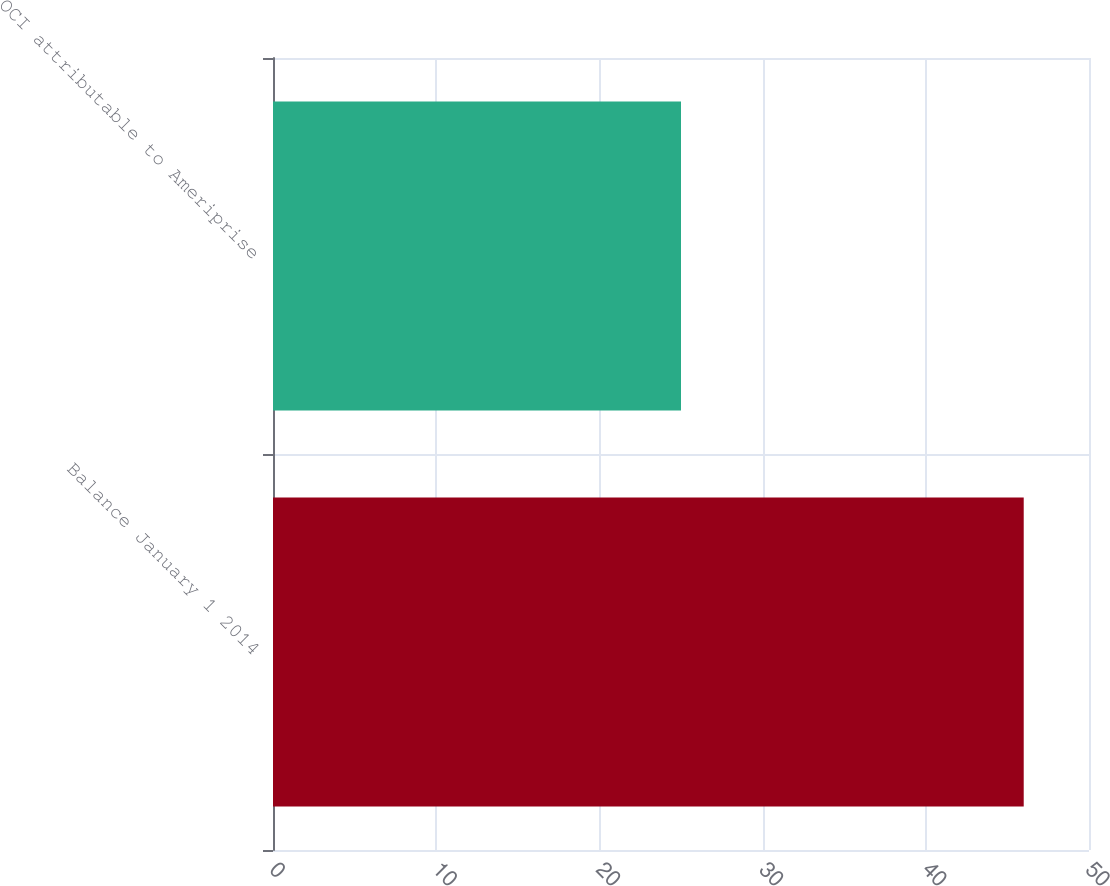<chart> <loc_0><loc_0><loc_500><loc_500><bar_chart><fcel>Balance January 1 2014<fcel>OCI attributable to Ameriprise<nl><fcel>46<fcel>25<nl></chart> 